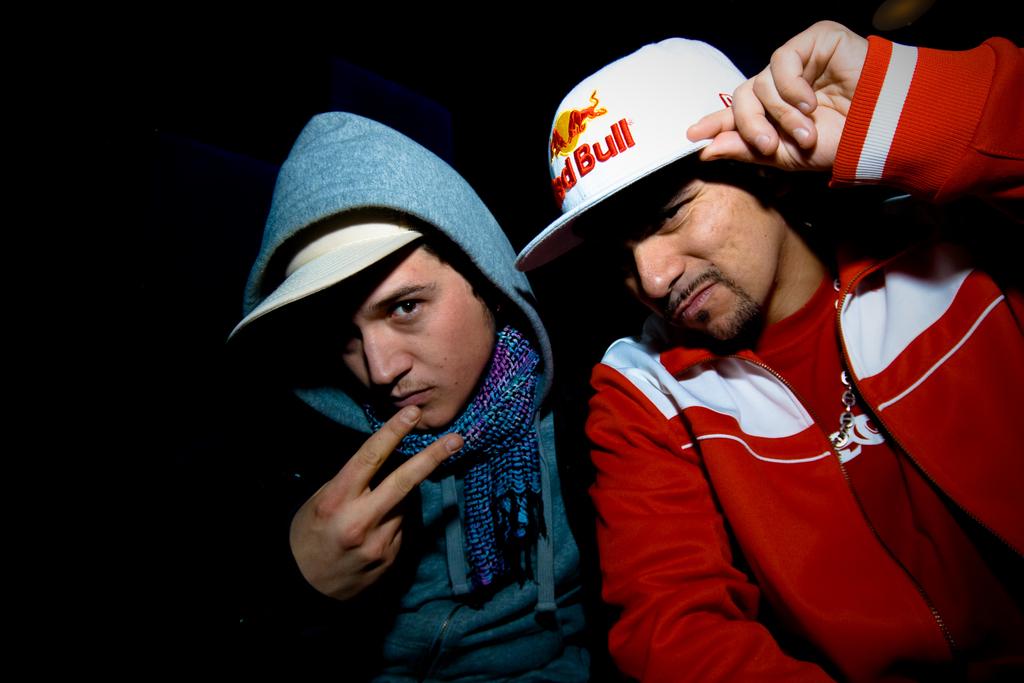What type of animal is written on his hat?
Your response must be concise. Bull. What is the brand on the hat?
Provide a succinct answer. Red bull. 